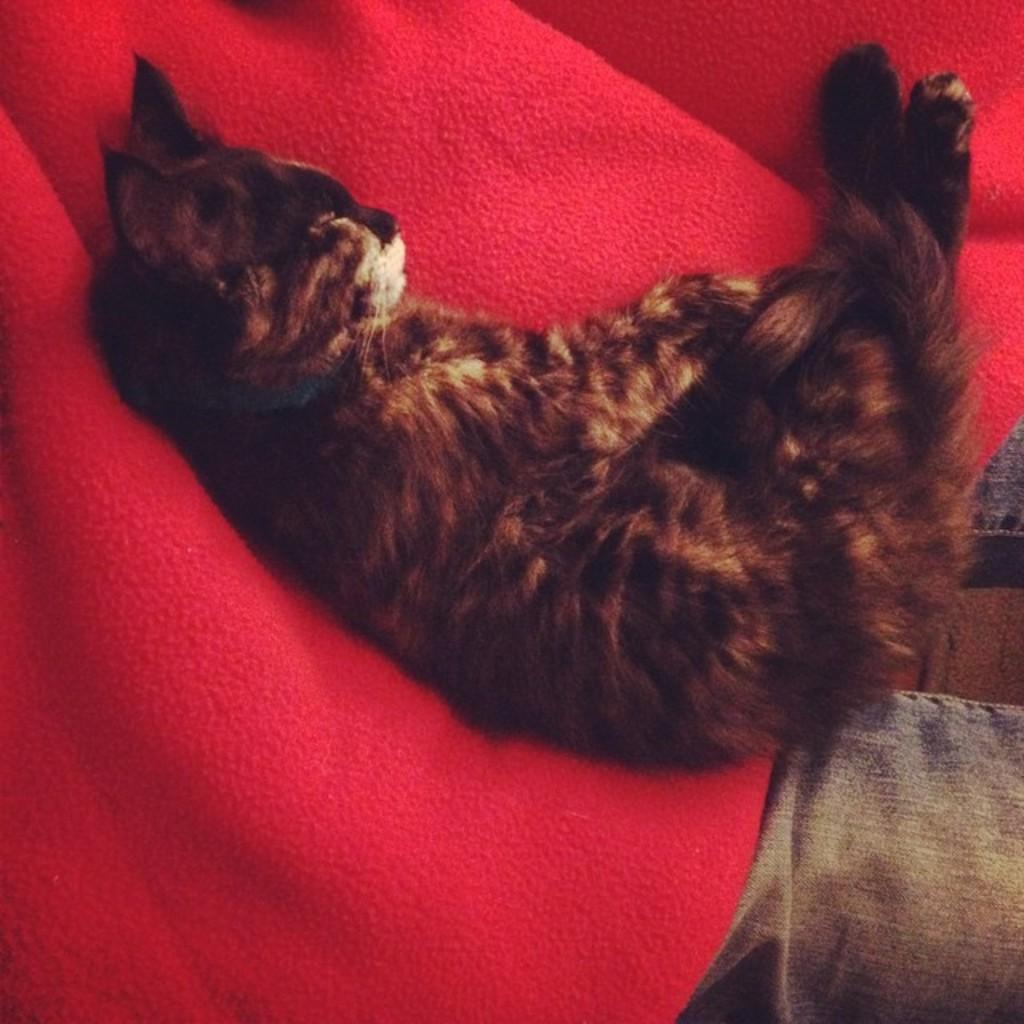What type of animal is in the image? There is a cat in the image. What is the cat doing in the image? The cat is sleeping. Where is the cat located in the image? The cat is on a person's shirt. Can you describe the person in the background of the image? There is a person with a red color shirt in the background of the image. What type of sheet is covering the cat in the image? There is no sheet covering the cat in the image; the cat is on a person's shirt. What kind of twig can be seen in the cat's paw in the image? There is no twig present in the image. 